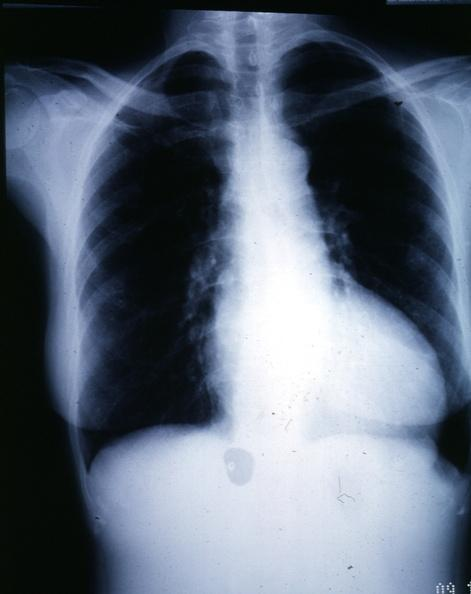s another fiber other frame present?
Answer the question using a single word or phrase. No 